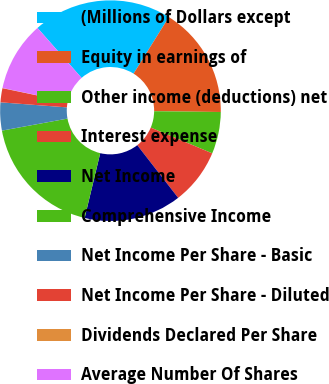<chart> <loc_0><loc_0><loc_500><loc_500><pie_chart><fcel>(Millions of Dollars except<fcel>Equity in earnings of<fcel>Other income (deductions) net<fcel>Interest expense<fcel>Net Income<fcel>Comprehensive Income<fcel>Net Income Per Share - Basic<fcel>Net Income Per Share - Diluted<fcel>Dividends Declared Per Share<fcel>Average Number Of Shares<nl><fcel>20.38%<fcel>16.31%<fcel>6.13%<fcel>8.17%<fcel>14.27%<fcel>18.35%<fcel>4.1%<fcel>2.06%<fcel>0.03%<fcel>10.2%<nl></chart> 